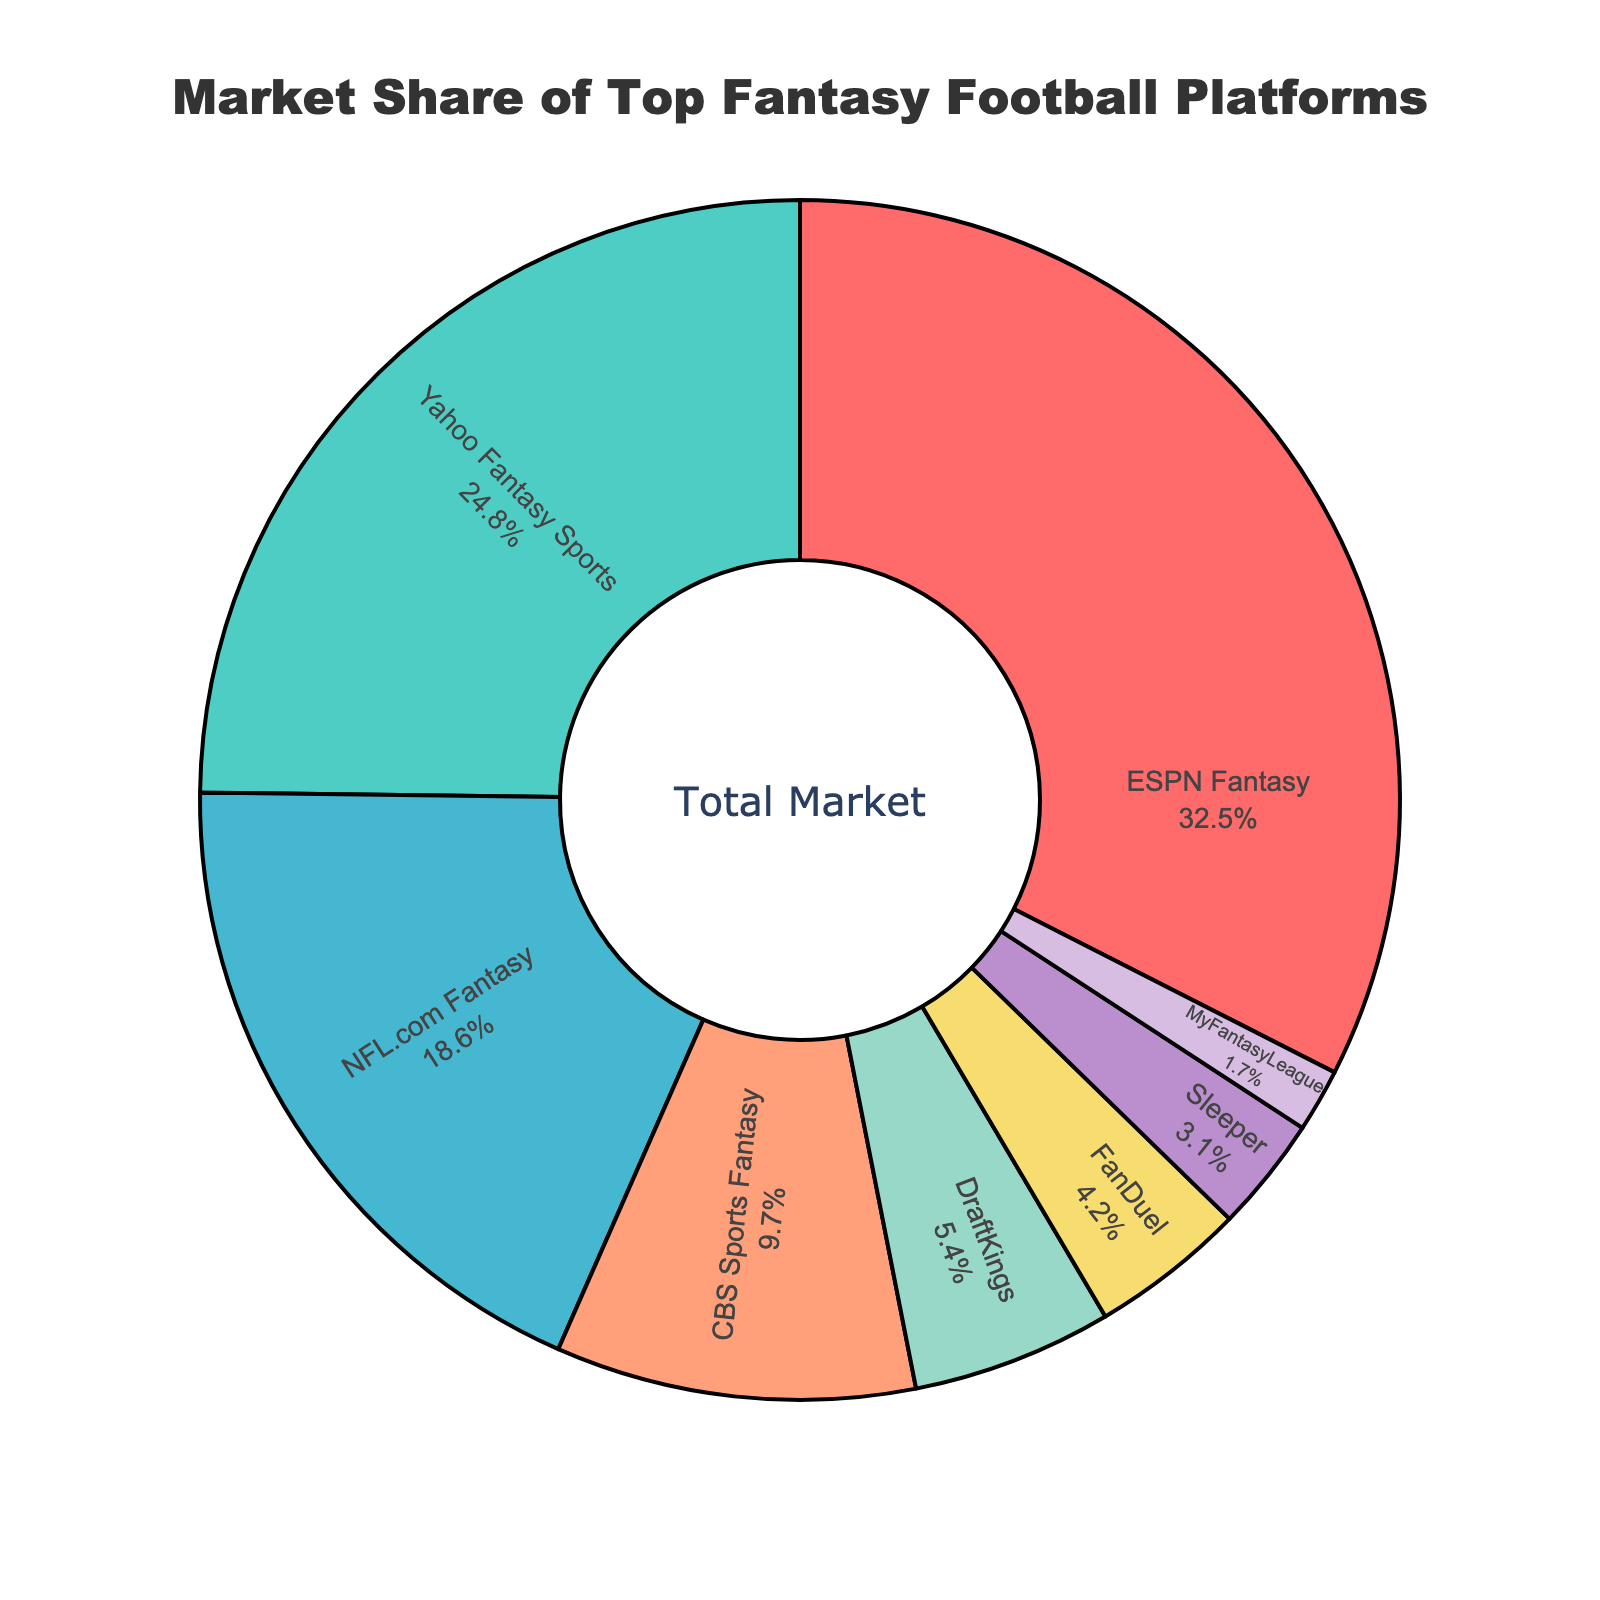Which platform has the highest market share? Looking at the figure, the platform with the largest slice in the pie chart is ESPN Fantasy. This segment is clearly marked with its label and the corresponding percentage, which is 32.5%.
Answer: ESPN Fantasy Which two platforms have a combined market share greater than 50%? Adding the market shares of the two largest segments from the pie chart, ESPN Fantasy (32.5%) and Yahoo Fantasy Sports (24.8%) gives 32.5 + 24.8 = 57.3%.
Answer: ESPN Fantasy and Yahoo Fantasy Sports How much more market share does DraftKings have compared to FanDuel? The pie chart shows the market shares of DraftKings and FanDuel as 5.4% and 4.2%, respectively. The difference is calculated by subtracting FanDuel's share from DraftKings' share: 5.4 - 4.2 = 1.2%.
Answer: 1.2% Which platform has the smallest market share, and what is that percentage? Observing the pie chart, the smallest slice belongs to MyFantasyLeague, which is labeled with a market share of 1.7%.
Answer: MyFantasyLeague, 1.7% What is the combined market share of the platforms with shares less than 10%? Summing the market shares of NFL.com Fantasy (18.6%) is more than 10%), CBS Sports Fantasy (9.7%), DraftKings (5.4%), FanDuel (4.2%), Sleeper (3.1%), and MyFantasyLeague (1.7%) gives 9.7 + 5.4 + 4.2 + 3.1 + 1.7 = 24.1%.
Answer: 24.1% What is the difference in market share between NFL.com Fantasy and CBS Sports Fantasy? The values shown in the pie chart for NFL.com Fantasy and CBS Sports Fantasy are 18.6% and 9.7%, respectively. By subtracting CBS Sports Fantasy's share from NFL.com Fantasy's share: 18.6 - 9.7 = 8.9%.
Answer: 8.9% How much more market share does the platform labeled in light blue have compared to the platform labeled in purple? The platform in light blue is Yahoo Fantasy Sports with 24.8%, and the one in purple is CBS Sports Fantasy with 9.7%. The difference is 24.8 - 9.7 = 15.1%.
Answer: 15.1% If we combine the market shares of ESPN Fantasy and NFL.com Fantasy, does their combined share exceed 50%? Adding the market shares of ESPN Fantasy (32.5%) and NFL.com Fantasy (18.6%) gives 32.5 + 18.6 = 51.1%.
Answer: Yes Which segment appears to be the second largest visually, and what is the corresponding percentage? The second largest segment, based on visual inspection, is Yahoo Fantasy Sports. The pie chart marks this segment with a market share of 24.8%.
Answer: Yahoo Fantasy Sports, 24.8% 